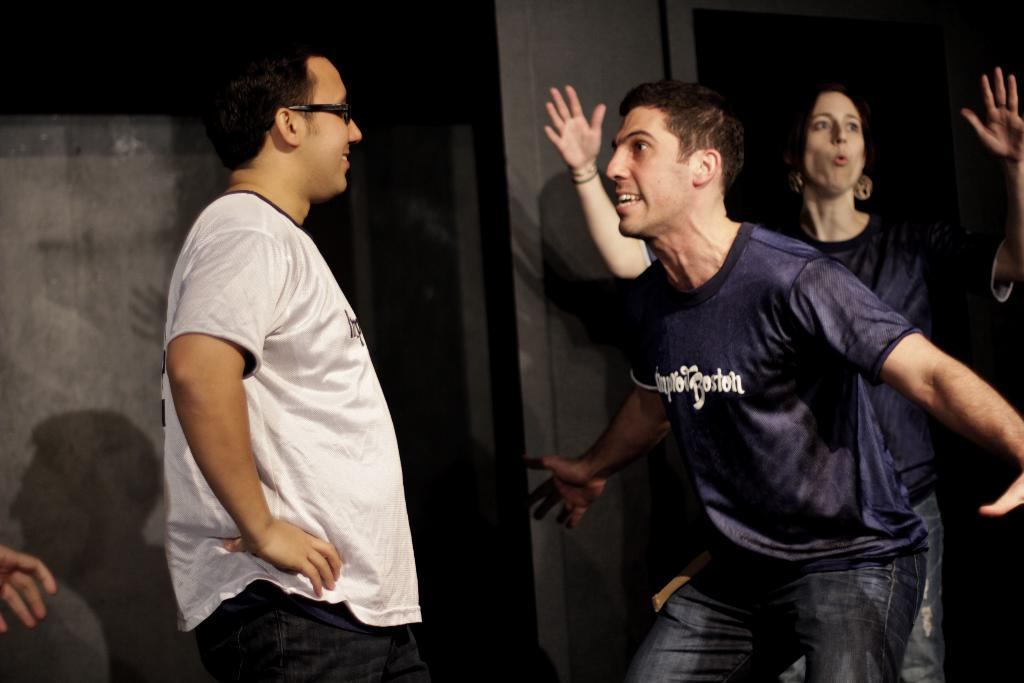How many people are present in the image? There are three people in the image: two men and one woman. Can you describe the background of the image? There is a wall in the background of the image. What type of machine is being operated by the woman in the image? There is no machine present in the image; it features two men and one woman. 